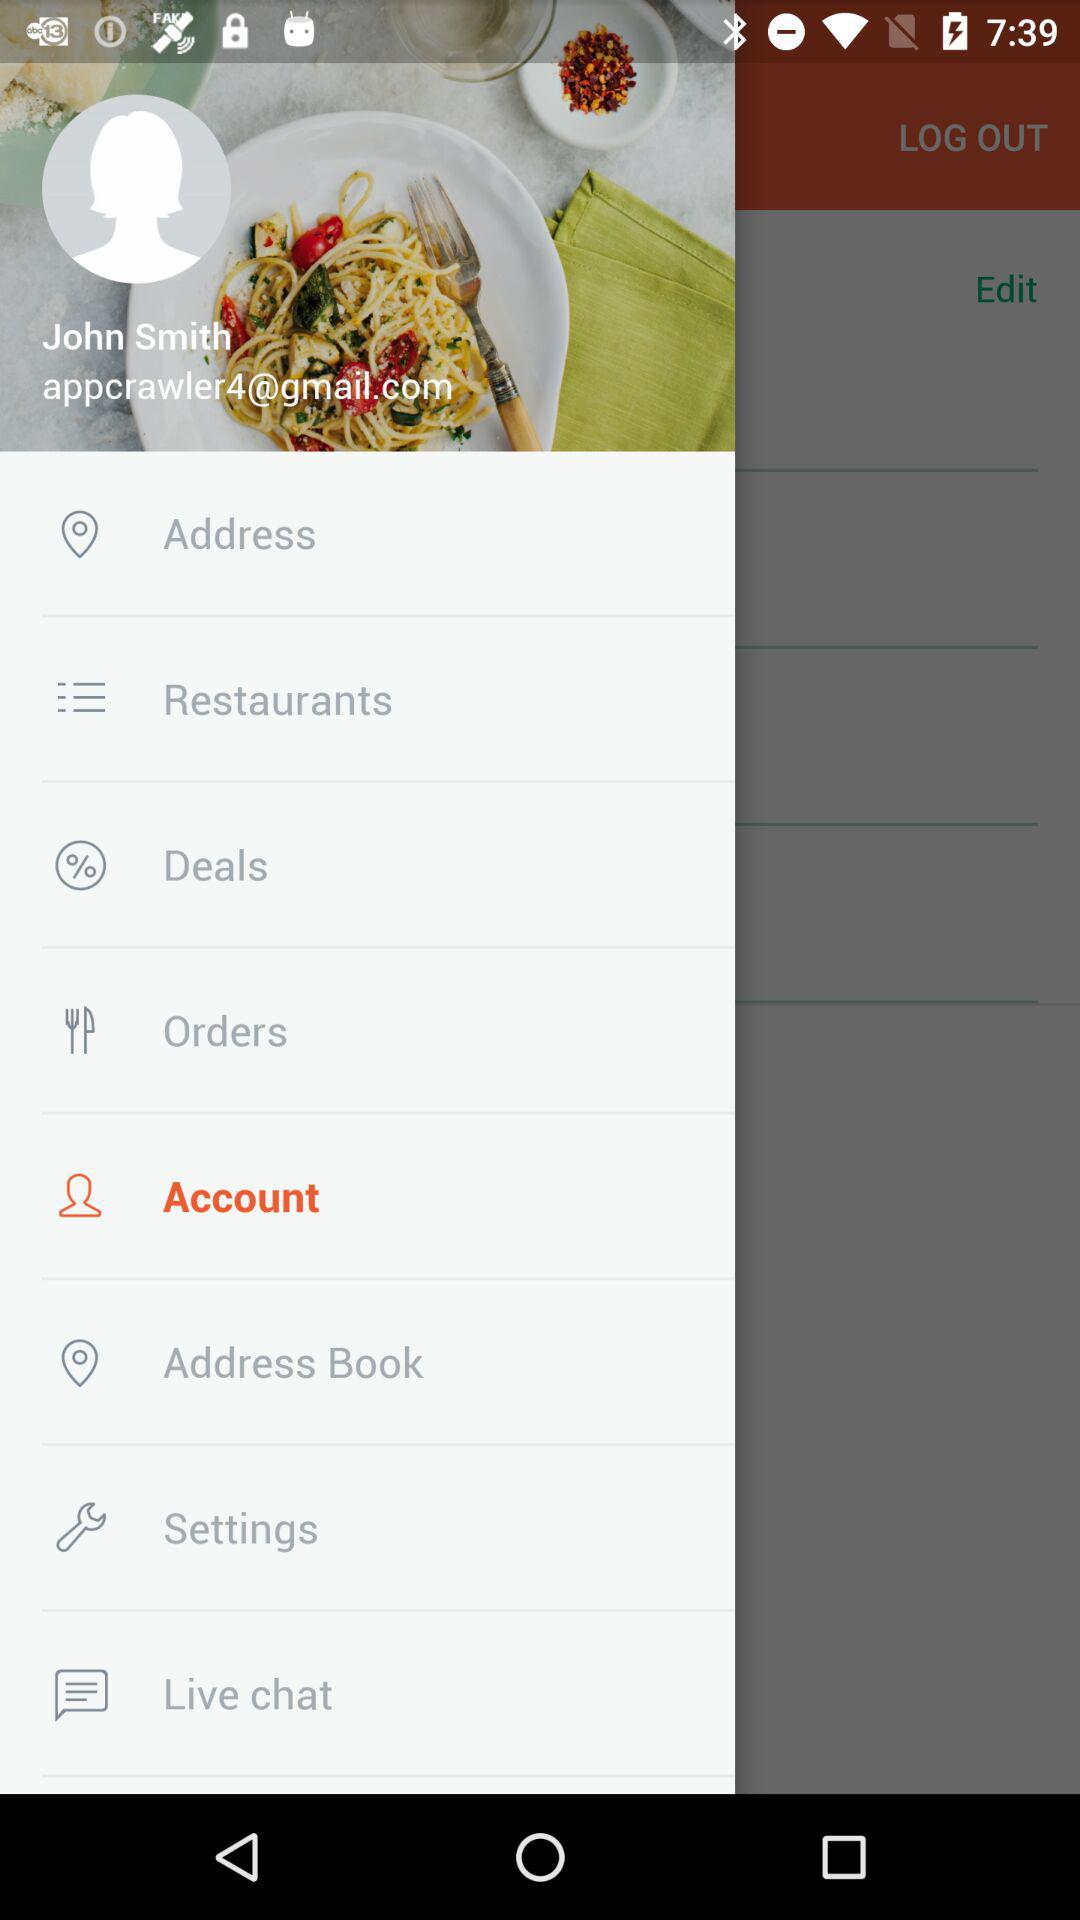Which option is selected? The selected option is "Account". 